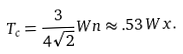Convert formula to latex. <formula><loc_0><loc_0><loc_500><loc_500>T _ { c } = \frac { 3 } { 4 \sqrt { 2 } } W n \approx . 5 3 \, W x .</formula> 